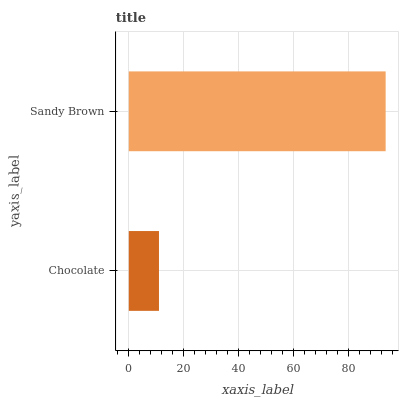Is Chocolate the minimum?
Answer yes or no. Yes. Is Sandy Brown the maximum?
Answer yes or no. Yes. Is Sandy Brown the minimum?
Answer yes or no. No. Is Sandy Brown greater than Chocolate?
Answer yes or no. Yes. Is Chocolate less than Sandy Brown?
Answer yes or no. Yes. Is Chocolate greater than Sandy Brown?
Answer yes or no. No. Is Sandy Brown less than Chocolate?
Answer yes or no. No. Is Sandy Brown the high median?
Answer yes or no. Yes. Is Chocolate the low median?
Answer yes or no. Yes. Is Chocolate the high median?
Answer yes or no. No. Is Sandy Brown the low median?
Answer yes or no. No. 